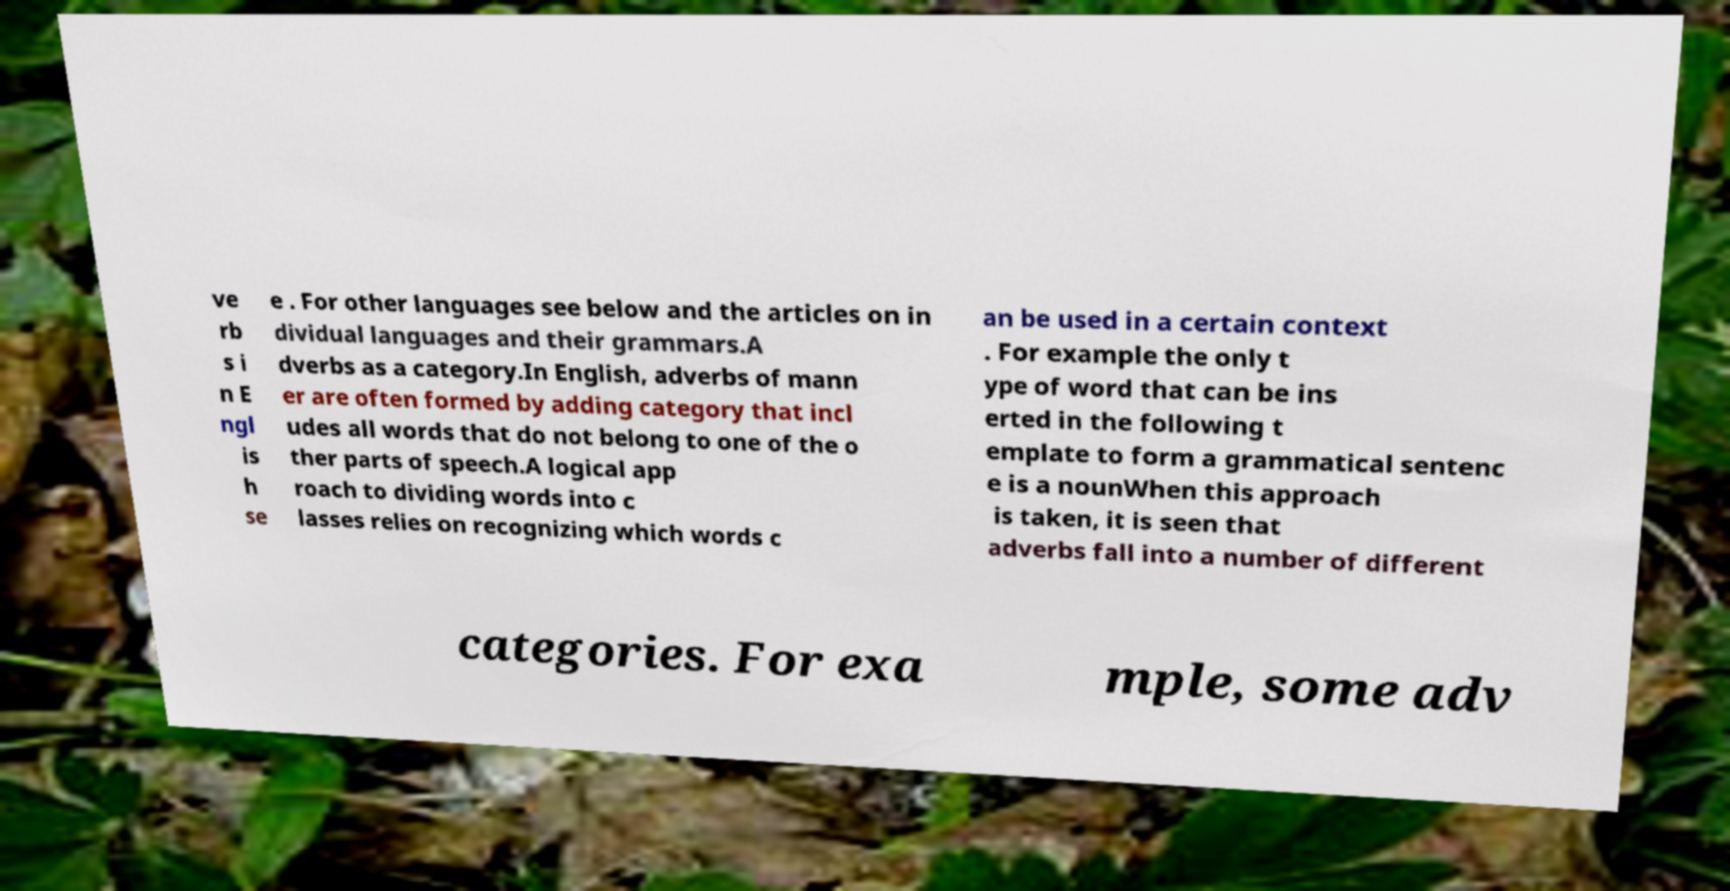Can you read and provide the text displayed in the image?This photo seems to have some interesting text. Can you extract and type it out for me? ve rb s i n E ngl is h se e . For other languages see below and the articles on in dividual languages and their grammars.A dverbs as a category.In English, adverbs of mann er are often formed by adding category that incl udes all words that do not belong to one of the o ther parts of speech.A logical app roach to dividing words into c lasses relies on recognizing which words c an be used in a certain context . For example the only t ype of word that can be ins erted in the following t emplate to form a grammatical sentenc e is a nounWhen this approach is taken, it is seen that adverbs fall into a number of different categories. For exa mple, some adv 